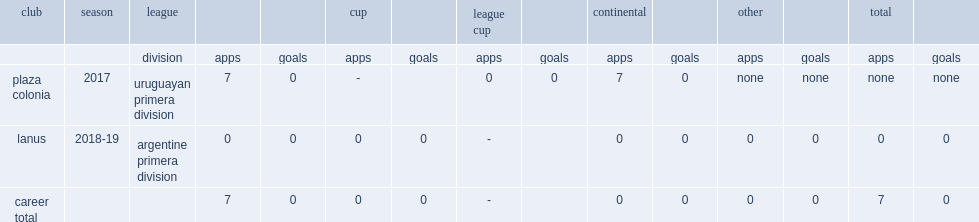Which division did matias soler participate in in 2017,in plaza colonia? Uruguayan primera division. 